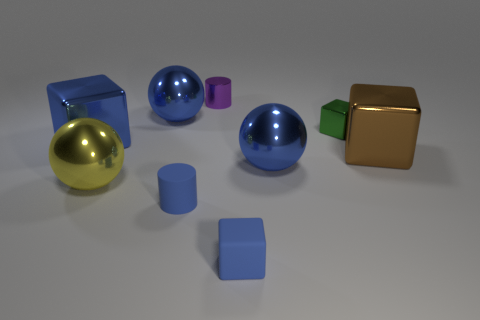Subtract all big brown metallic blocks. How many blocks are left? 3 Subtract all brown cylinders. How many blue cubes are left? 2 Add 1 tiny green rubber things. How many objects exist? 10 Subtract all yellow balls. How many balls are left? 2 Subtract all cylinders. How many objects are left? 7 Subtract all red cubes. Subtract all brown spheres. How many cubes are left? 4 Subtract all big blue metal things. Subtract all blue blocks. How many objects are left? 4 Add 5 yellow shiny balls. How many yellow shiny balls are left? 6 Add 3 tiny blue matte cylinders. How many tiny blue matte cylinders exist? 4 Subtract 1 purple cylinders. How many objects are left? 8 